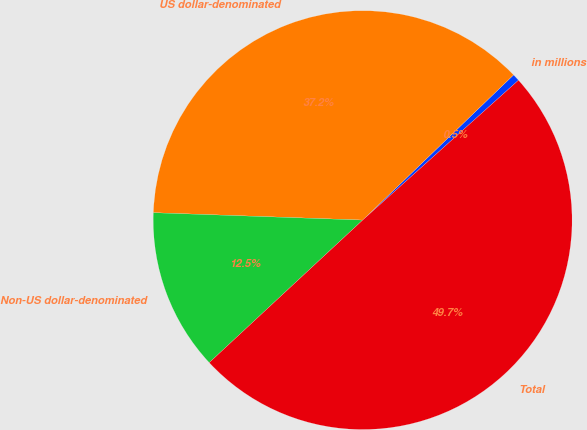Convert chart to OTSL. <chart><loc_0><loc_0><loc_500><loc_500><pie_chart><fcel>in millions<fcel>US dollar-denominated<fcel>Non-US dollar-denominated<fcel>Total<nl><fcel>0.55%<fcel>37.25%<fcel>12.48%<fcel>49.73%<nl></chart> 